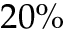<formula> <loc_0><loc_0><loc_500><loc_500>2 0 \%</formula> 